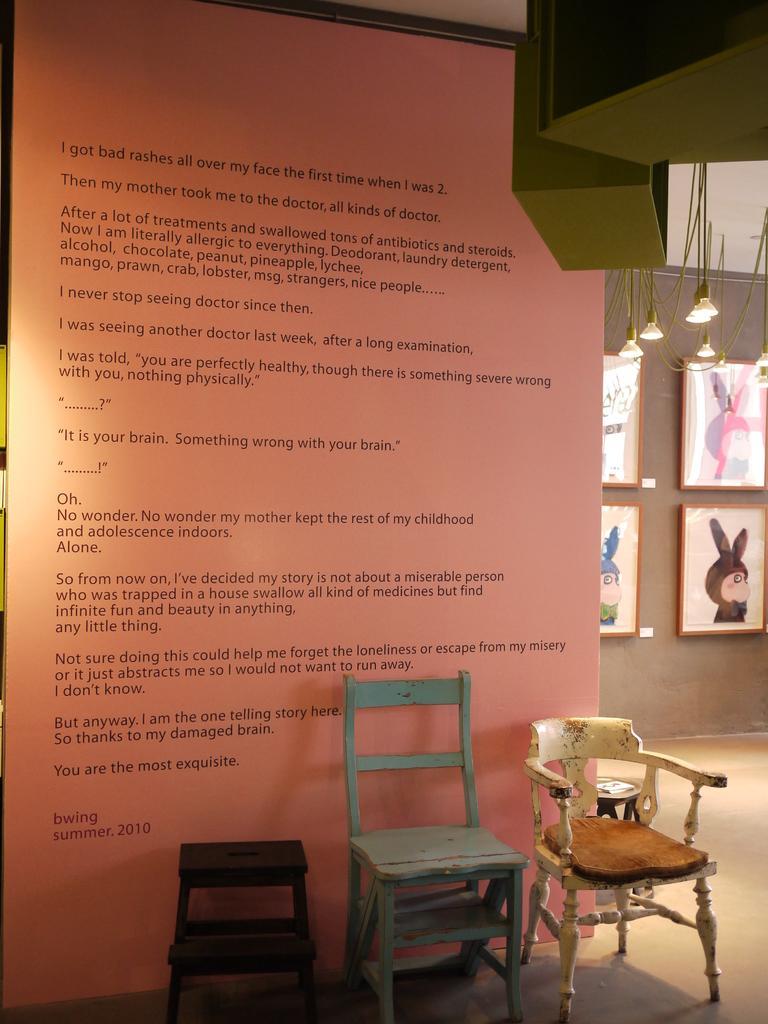Can you describe this image briefly? In this picture it looks like some text on the wall in front of which 3 chairs are there. On the right side we have photos frames on the wall and lights hanging from the ceiling. 